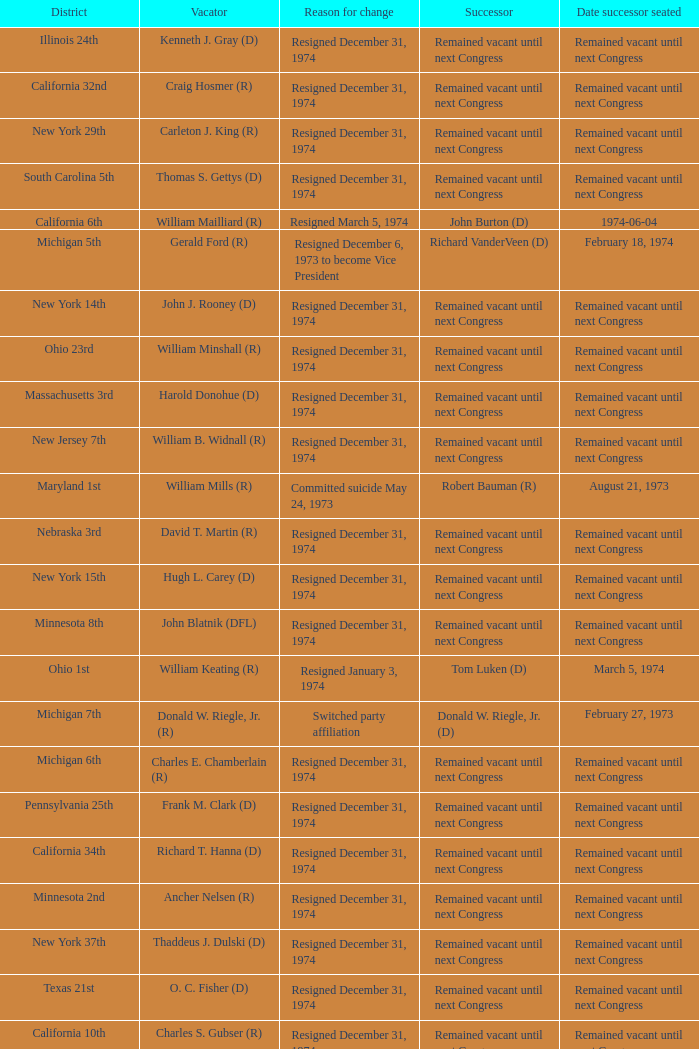When was the date successor seated when the vacator was charles e. chamberlain (r)? Remained vacant until next Congress. 